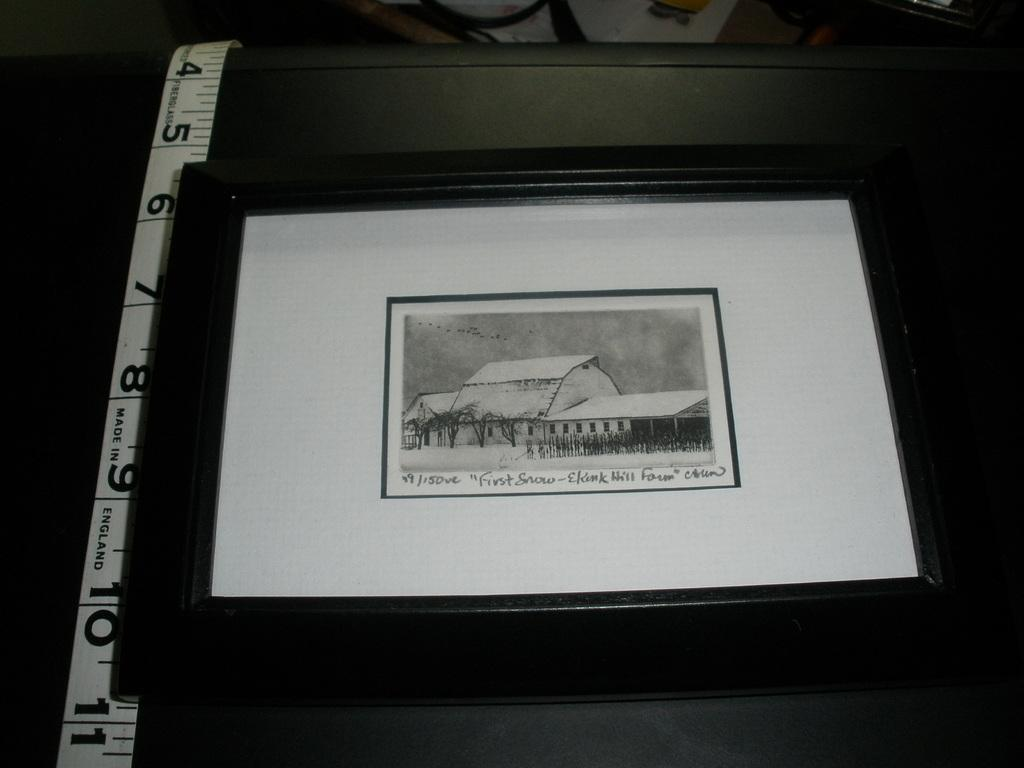<image>
Provide a brief description of the given image. a photo of first snow in some place 